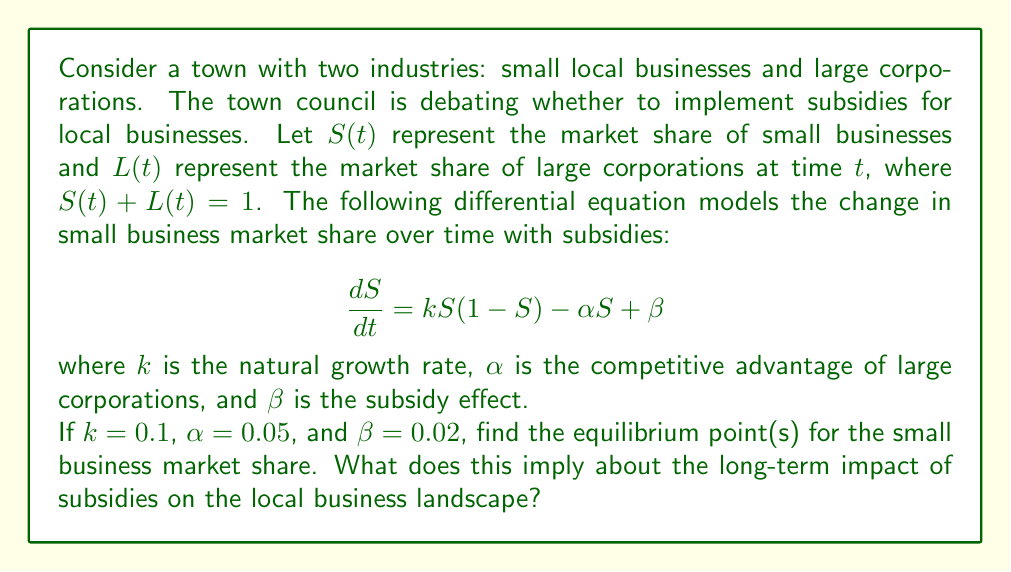What is the answer to this math problem? To solve this problem, we need to find the equilibrium point(s) where $\frac{dS}{dt} = 0$. This will give us the stable market share for small businesses under the given conditions.

1) Set the differential equation to zero:
   $$\frac{dS}{dt} = kS(1-S) - \alpha S + \beta = 0$$

2) Substitute the given values:
   $$0.1S(1-S) - 0.05S + 0.02 = 0$$

3) Expand the equation:
   $$0.1S - 0.1S^2 - 0.05S + 0.02 = 0$$
   $$-0.1S^2 + 0.05S + 0.02 = 0$$

4) This is a quadratic equation. Let's rearrange it to standard form:
   $$0.1S^2 - 0.05S - 0.02 = 0$$

5) We can solve this using the quadratic formula: $S = \frac{-b \pm \sqrt{b^2 - 4ac}}{2a}$
   Where $a = 0.1$, $b = -0.05$, and $c = -0.02$

6) Plugging in these values:
   $$S = \frac{0.05 \pm \sqrt{(-0.05)^2 - 4(0.1)(-0.02)}}{2(0.1)}$$
   $$= \frac{0.05 \pm \sqrt{0.0025 + 0.008}}{0.2}$$
   $$= \frac{0.05 \pm \sqrt{0.0105}}{0.2}$$
   $$= \frac{0.05 \pm 0.1025}{0.2}$$

7) This gives us two solutions:
   $$S_1 = \frac{0.05 + 0.1025}{0.2} = 0.7625$$
   $$S_2 = \frac{0.05 - 0.1025}{0.2} = -0.2625$$

8) Since market share cannot be negative, we discard the negative solution.

The equilibrium point is therefore $S = 0.7625$ or 76.25% market share for small businesses.

This implies that with the given subsidy effect, small local businesses will eventually dominate the market, holding over three-quarters of the market share in the long term. This result suggests that the subsidies have a significant impact on the local business landscape, potentially leading to an imbalance in favor of small businesses.
Answer: The equilibrium point is $S = 0.7625$ or 76.25% market share for small businesses. 